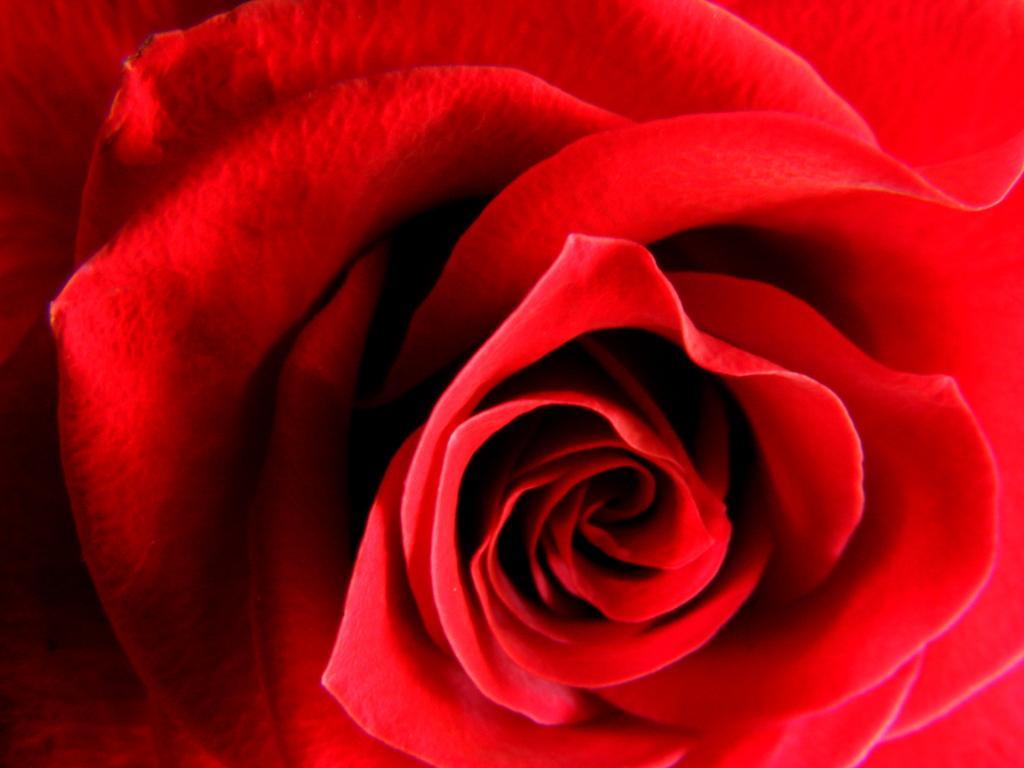How would you summarize this image in a sentence or two? In this picture we can see a red color rose flower, we can see petals of the flower here. 